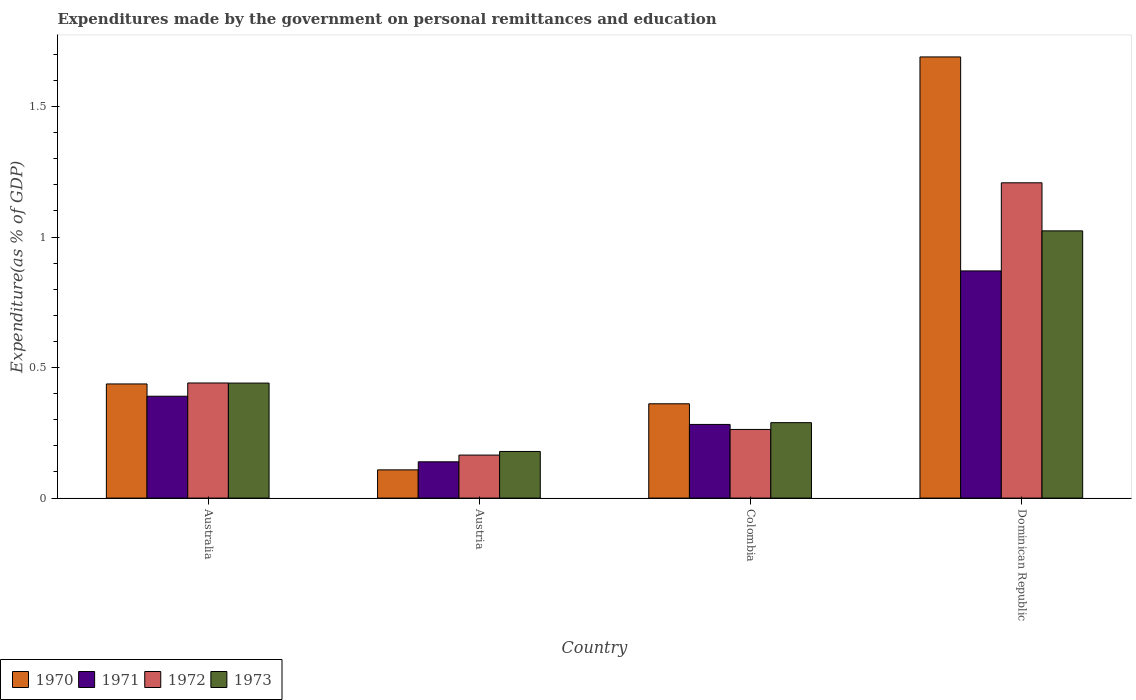How many bars are there on the 1st tick from the left?
Provide a short and direct response. 4. How many bars are there on the 1st tick from the right?
Give a very brief answer. 4. What is the expenditures made by the government on personal remittances and education in 1972 in Dominican Republic?
Ensure brevity in your answer.  1.21. Across all countries, what is the maximum expenditures made by the government on personal remittances and education in 1972?
Offer a very short reply. 1.21. Across all countries, what is the minimum expenditures made by the government on personal remittances and education in 1971?
Make the answer very short. 0.14. In which country was the expenditures made by the government on personal remittances and education in 1971 maximum?
Ensure brevity in your answer.  Dominican Republic. What is the total expenditures made by the government on personal remittances and education in 1971 in the graph?
Offer a terse response. 1.68. What is the difference between the expenditures made by the government on personal remittances and education in 1972 in Australia and that in Dominican Republic?
Keep it short and to the point. -0.77. What is the difference between the expenditures made by the government on personal remittances and education in 1972 in Dominican Republic and the expenditures made by the government on personal remittances and education in 1971 in Austria?
Offer a very short reply. 1.07. What is the average expenditures made by the government on personal remittances and education in 1970 per country?
Keep it short and to the point. 0.65. What is the difference between the expenditures made by the government on personal remittances and education of/in 1971 and expenditures made by the government on personal remittances and education of/in 1970 in Dominican Republic?
Make the answer very short. -0.82. In how many countries, is the expenditures made by the government on personal remittances and education in 1972 greater than 1.6 %?
Keep it short and to the point. 0. What is the ratio of the expenditures made by the government on personal remittances and education in 1971 in Austria to that in Dominican Republic?
Provide a succinct answer. 0.16. Is the expenditures made by the government on personal remittances and education in 1971 in Australia less than that in Colombia?
Your response must be concise. No. Is the difference between the expenditures made by the government on personal remittances and education in 1971 in Austria and Dominican Republic greater than the difference between the expenditures made by the government on personal remittances and education in 1970 in Austria and Dominican Republic?
Ensure brevity in your answer.  Yes. What is the difference between the highest and the second highest expenditures made by the government on personal remittances and education in 1970?
Ensure brevity in your answer.  -1.25. What is the difference between the highest and the lowest expenditures made by the government on personal remittances and education in 1971?
Your answer should be compact. 0.73. In how many countries, is the expenditures made by the government on personal remittances and education in 1972 greater than the average expenditures made by the government on personal remittances and education in 1972 taken over all countries?
Provide a short and direct response. 1. What does the 3rd bar from the left in Australia represents?
Your answer should be compact. 1972. What does the 2nd bar from the right in Austria represents?
Give a very brief answer. 1972. Are all the bars in the graph horizontal?
Offer a very short reply. No. How many countries are there in the graph?
Provide a succinct answer. 4. Where does the legend appear in the graph?
Give a very brief answer. Bottom left. How many legend labels are there?
Make the answer very short. 4. What is the title of the graph?
Keep it short and to the point. Expenditures made by the government on personal remittances and education. What is the label or title of the Y-axis?
Your answer should be very brief. Expenditure(as % of GDP). What is the Expenditure(as % of GDP) in 1970 in Australia?
Your response must be concise. 0.44. What is the Expenditure(as % of GDP) of 1971 in Australia?
Ensure brevity in your answer.  0.39. What is the Expenditure(as % of GDP) in 1972 in Australia?
Provide a short and direct response. 0.44. What is the Expenditure(as % of GDP) of 1973 in Australia?
Your answer should be very brief. 0.44. What is the Expenditure(as % of GDP) of 1970 in Austria?
Ensure brevity in your answer.  0.11. What is the Expenditure(as % of GDP) of 1971 in Austria?
Give a very brief answer. 0.14. What is the Expenditure(as % of GDP) of 1972 in Austria?
Offer a terse response. 0.16. What is the Expenditure(as % of GDP) of 1973 in Austria?
Your answer should be very brief. 0.18. What is the Expenditure(as % of GDP) of 1970 in Colombia?
Ensure brevity in your answer.  0.36. What is the Expenditure(as % of GDP) of 1971 in Colombia?
Offer a very short reply. 0.28. What is the Expenditure(as % of GDP) in 1972 in Colombia?
Provide a succinct answer. 0.26. What is the Expenditure(as % of GDP) in 1973 in Colombia?
Make the answer very short. 0.29. What is the Expenditure(as % of GDP) of 1970 in Dominican Republic?
Offer a terse response. 1.69. What is the Expenditure(as % of GDP) of 1971 in Dominican Republic?
Provide a succinct answer. 0.87. What is the Expenditure(as % of GDP) in 1972 in Dominican Republic?
Your answer should be very brief. 1.21. What is the Expenditure(as % of GDP) in 1973 in Dominican Republic?
Provide a short and direct response. 1.02. Across all countries, what is the maximum Expenditure(as % of GDP) in 1970?
Give a very brief answer. 1.69. Across all countries, what is the maximum Expenditure(as % of GDP) in 1971?
Make the answer very short. 0.87. Across all countries, what is the maximum Expenditure(as % of GDP) in 1972?
Provide a succinct answer. 1.21. Across all countries, what is the maximum Expenditure(as % of GDP) of 1973?
Make the answer very short. 1.02. Across all countries, what is the minimum Expenditure(as % of GDP) in 1970?
Offer a terse response. 0.11. Across all countries, what is the minimum Expenditure(as % of GDP) of 1971?
Make the answer very short. 0.14. Across all countries, what is the minimum Expenditure(as % of GDP) in 1972?
Ensure brevity in your answer.  0.16. Across all countries, what is the minimum Expenditure(as % of GDP) in 1973?
Your answer should be compact. 0.18. What is the total Expenditure(as % of GDP) in 1970 in the graph?
Your response must be concise. 2.6. What is the total Expenditure(as % of GDP) in 1971 in the graph?
Provide a short and direct response. 1.68. What is the total Expenditure(as % of GDP) in 1972 in the graph?
Your answer should be compact. 2.08. What is the total Expenditure(as % of GDP) of 1973 in the graph?
Provide a short and direct response. 1.93. What is the difference between the Expenditure(as % of GDP) in 1970 in Australia and that in Austria?
Your answer should be very brief. 0.33. What is the difference between the Expenditure(as % of GDP) in 1971 in Australia and that in Austria?
Provide a short and direct response. 0.25. What is the difference between the Expenditure(as % of GDP) in 1972 in Australia and that in Austria?
Offer a very short reply. 0.28. What is the difference between the Expenditure(as % of GDP) in 1973 in Australia and that in Austria?
Offer a very short reply. 0.26. What is the difference between the Expenditure(as % of GDP) in 1970 in Australia and that in Colombia?
Provide a short and direct response. 0.08. What is the difference between the Expenditure(as % of GDP) in 1971 in Australia and that in Colombia?
Ensure brevity in your answer.  0.11. What is the difference between the Expenditure(as % of GDP) in 1972 in Australia and that in Colombia?
Provide a short and direct response. 0.18. What is the difference between the Expenditure(as % of GDP) in 1973 in Australia and that in Colombia?
Give a very brief answer. 0.15. What is the difference between the Expenditure(as % of GDP) in 1970 in Australia and that in Dominican Republic?
Provide a succinct answer. -1.25. What is the difference between the Expenditure(as % of GDP) in 1971 in Australia and that in Dominican Republic?
Your answer should be compact. -0.48. What is the difference between the Expenditure(as % of GDP) of 1972 in Australia and that in Dominican Republic?
Ensure brevity in your answer.  -0.77. What is the difference between the Expenditure(as % of GDP) of 1973 in Australia and that in Dominican Republic?
Provide a short and direct response. -0.58. What is the difference between the Expenditure(as % of GDP) in 1970 in Austria and that in Colombia?
Give a very brief answer. -0.25. What is the difference between the Expenditure(as % of GDP) of 1971 in Austria and that in Colombia?
Your answer should be very brief. -0.14. What is the difference between the Expenditure(as % of GDP) in 1972 in Austria and that in Colombia?
Your response must be concise. -0.1. What is the difference between the Expenditure(as % of GDP) in 1973 in Austria and that in Colombia?
Your answer should be compact. -0.11. What is the difference between the Expenditure(as % of GDP) of 1970 in Austria and that in Dominican Republic?
Offer a terse response. -1.58. What is the difference between the Expenditure(as % of GDP) of 1971 in Austria and that in Dominican Republic?
Offer a terse response. -0.73. What is the difference between the Expenditure(as % of GDP) in 1972 in Austria and that in Dominican Republic?
Your answer should be compact. -1.04. What is the difference between the Expenditure(as % of GDP) in 1973 in Austria and that in Dominican Republic?
Offer a very short reply. -0.84. What is the difference between the Expenditure(as % of GDP) in 1970 in Colombia and that in Dominican Republic?
Keep it short and to the point. -1.33. What is the difference between the Expenditure(as % of GDP) in 1971 in Colombia and that in Dominican Republic?
Offer a very short reply. -0.59. What is the difference between the Expenditure(as % of GDP) of 1972 in Colombia and that in Dominican Republic?
Make the answer very short. -0.94. What is the difference between the Expenditure(as % of GDP) in 1973 in Colombia and that in Dominican Republic?
Your answer should be very brief. -0.73. What is the difference between the Expenditure(as % of GDP) of 1970 in Australia and the Expenditure(as % of GDP) of 1971 in Austria?
Ensure brevity in your answer.  0.3. What is the difference between the Expenditure(as % of GDP) in 1970 in Australia and the Expenditure(as % of GDP) in 1972 in Austria?
Your response must be concise. 0.27. What is the difference between the Expenditure(as % of GDP) in 1970 in Australia and the Expenditure(as % of GDP) in 1973 in Austria?
Ensure brevity in your answer.  0.26. What is the difference between the Expenditure(as % of GDP) of 1971 in Australia and the Expenditure(as % of GDP) of 1972 in Austria?
Ensure brevity in your answer.  0.23. What is the difference between the Expenditure(as % of GDP) in 1971 in Australia and the Expenditure(as % of GDP) in 1973 in Austria?
Offer a terse response. 0.21. What is the difference between the Expenditure(as % of GDP) in 1972 in Australia and the Expenditure(as % of GDP) in 1973 in Austria?
Give a very brief answer. 0.26. What is the difference between the Expenditure(as % of GDP) of 1970 in Australia and the Expenditure(as % of GDP) of 1971 in Colombia?
Your response must be concise. 0.15. What is the difference between the Expenditure(as % of GDP) of 1970 in Australia and the Expenditure(as % of GDP) of 1972 in Colombia?
Your answer should be compact. 0.17. What is the difference between the Expenditure(as % of GDP) of 1970 in Australia and the Expenditure(as % of GDP) of 1973 in Colombia?
Provide a short and direct response. 0.15. What is the difference between the Expenditure(as % of GDP) in 1971 in Australia and the Expenditure(as % of GDP) in 1972 in Colombia?
Your response must be concise. 0.13. What is the difference between the Expenditure(as % of GDP) in 1971 in Australia and the Expenditure(as % of GDP) in 1973 in Colombia?
Keep it short and to the point. 0.1. What is the difference between the Expenditure(as % of GDP) of 1972 in Australia and the Expenditure(as % of GDP) of 1973 in Colombia?
Keep it short and to the point. 0.15. What is the difference between the Expenditure(as % of GDP) of 1970 in Australia and the Expenditure(as % of GDP) of 1971 in Dominican Republic?
Provide a short and direct response. -0.43. What is the difference between the Expenditure(as % of GDP) of 1970 in Australia and the Expenditure(as % of GDP) of 1972 in Dominican Republic?
Offer a very short reply. -0.77. What is the difference between the Expenditure(as % of GDP) of 1970 in Australia and the Expenditure(as % of GDP) of 1973 in Dominican Republic?
Provide a short and direct response. -0.59. What is the difference between the Expenditure(as % of GDP) in 1971 in Australia and the Expenditure(as % of GDP) in 1972 in Dominican Republic?
Give a very brief answer. -0.82. What is the difference between the Expenditure(as % of GDP) in 1971 in Australia and the Expenditure(as % of GDP) in 1973 in Dominican Republic?
Your answer should be compact. -0.63. What is the difference between the Expenditure(as % of GDP) of 1972 in Australia and the Expenditure(as % of GDP) of 1973 in Dominican Republic?
Your response must be concise. -0.58. What is the difference between the Expenditure(as % of GDP) in 1970 in Austria and the Expenditure(as % of GDP) in 1971 in Colombia?
Keep it short and to the point. -0.17. What is the difference between the Expenditure(as % of GDP) of 1970 in Austria and the Expenditure(as % of GDP) of 1972 in Colombia?
Your answer should be compact. -0.15. What is the difference between the Expenditure(as % of GDP) of 1970 in Austria and the Expenditure(as % of GDP) of 1973 in Colombia?
Ensure brevity in your answer.  -0.18. What is the difference between the Expenditure(as % of GDP) of 1971 in Austria and the Expenditure(as % of GDP) of 1972 in Colombia?
Keep it short and to the point. -0.12. What is the difference between the Expenditure(as % of GDP) of 1971 in Austria and the Expenditure(as % of GDP) of 1973 in Colombia?
Provide a succinct answer. -0.15. What is the difference between the Expenditure(as % of GDP) in 1972 in Austria and the Expenditure(as % of GDP) in 1973 in Colombia?
Your answer should be very brief. -0.12. What is the difference between the Expenditure(as % of GDP) in 1970 in Austria and the Expenditure(as % of GDP) in 1971 in Dominican Republic?
Your answer should be compact. -0.76. What is the difference between the Expenditure(as % of GDP) of 1970 in Austria and the Expenditure(as % of GDP) of 1972 in Dominican Republic?
Your answer should be compact. -1.1. What is the difference between the Expenditure(as % of GDP) of 1970 in Austria and the Expenditure(as % of GDP) of 1973 in Dominican Republic?
Make the answer very short. -0.92. What is the difference between the Expenditure(as % of GDP) of 1971 in Austria and the Expenditure(as % of GDP) of 1972 in Dominican Republic?
Provide a short and direct response. -1.07. What is the difference between the Expenditure(as % of GDP) of 1971 in Austria and the Expenditure(as % of GDP) of 1973 in Dominican Republic?
Keep it short and to the point. -0.88. What is the difference between the Expenditure(as % of GDP) in 1972 in Austria and the Expenditure(as % of GDP) in 1973 in Dominican Republic?
Keep it short and to the point. -0.86. What is the difference between the Expenditure(as % of GDP) in 1970 in Colombia and the Expenditure(as % of GDP) in 1971 in Dominican Republic?
Provide a succinct answer. -0.51. What is the difference between the Expenditure(as % of GDP) of 1970 in Colombia and the Expenditure(as % of GDP) of 1972 in Dominican Republic?
Give a very brief answer. -0.85. What is the difference between the Expenditure(as % of GDP) of 1970 in Colombia and the Expenditure(as % of GDP) of 1973 in Dominican Republic?
Your answer should be very brief. -0.66. What is the difference between the Expenditure(as % of GDP) in 1971 in Colombia and the Expenditure(as % of GDP) in 1972 in Dominican Republic?
Provide a short and direct response. -0.93. What is the difference between the Expenditure(as % of GDP) of 1971 in Colombia and the Expenditure(as % of GDP) of 1973 in Dominican Republic?
Your answer should be very brief. -0.74. What is the difference between the Expenditure(as % of GDP) in 1972 in Colombia and the Expenditure(as % of GDP) in 1973 in Dominican Republic?
Offer a very short reply. -0.76. What is the average Expenditure(as % of GDP) in 1970 per country?
Ensure brevity in your answer.  0.65. What is the average Expenditure(as % of GDP) of 1971 per country?
Your answer should be very brief. 0.42. What is the average Expenditure(as % of GDP) in 1972 per country?
Provide a succinct answer. 0.52. What is the average Expenditure(as % of GDP) in 1973 per country?
Your answer should be compact. 0.48. What is the difference between the Expenditure(as % of GDP) in 1970 and Expenditure(as % of GDP) in 1971 in Australia?
Your answer should be compact. 0.05. What is the difference between the Expenditure(as % of GDP) in 1970 and Expenditure(as % of GDP) in 1972 in Australia?
Your answer should be compact. -0. What is the difference between the Expenditure(as % of GDP) in 1970 and Expenditure(as % of GDP) in 1973 in Australia?
Keep it short and to the point. -0. What is the difference between the Expenditure(as % of GDP) in 1971 and Expenditure(as % of GDP) in 1972 in Australia?
Your response must be concise. -0.05. What is the difference between the Expenditure(as % of GDP) in 1971 and Expenditure(as % of GDP) in 1973 in Australia?
Your response must be concise. -0.05. What is the difference between the Expenditure(as % of GDP) of 1970 and Expenditure(as % of GDP) of 1971 in Austria?
Ensure brevity in your answer.  -0.03. What is the difference between the Expenditure(as % of GDP) in 1970 and Expenditure(as % of GDP) in 1972 in Austria?
Offer a very short reply. -0.06. What is the difference between the Expenditure(as % of GDP) in 1970 and Expenditure(as % of GDP) in 1973 in Austria?
Offer a very short reply. -0.07. What is the difference between the Expenditure(as % of GDP) of 1971 and Expenditure(as % of GDP) of 1972 in Austria?
Provide a succinct answer. -0.03. What is the difference between the Expenditure(as % of GDP) in 1971 and Expenditure(as % of GDP) in 1973 in Austria?
Make the answer very short. -0.04. What is the difference between the Expenditure(as % of GDP) in 1972 and Expenditure(as % of GDP) in 1973 in Austria?
Make the answer very short. -0.01. What is the difference between the Expenditure(as % of GDP) in 1970 and Expenditure(as % of GDP) in 1971 in Colombia?
Provide a short and direct response. 0.08. What is the difference between the Expenditure(as % of GDP) of 1970 and Expenditure(as % of GDP) of 1972 in Colombia?
Ensure brevity in your answer.  0.1. What is the difference between the Expenditure(as % of GDP) of 1970 and Expenditure(as % of GDP) of 1973 in Colombia?
Provide a succinct answer. 0.07. What is the difference between the Expenditure(as % of GDP) of 1971 and Expenditure(as % of GDP) of 1972 in Colombia?
Offer a very short reply. 0.02. What is the difference between the Expenditure(as % of GDP) in 1971 and Expenditure(as % of GDP) in 1973 in Colombia?
Offer a terse response. -0.01. What is the difference between the Expenditure(as % of GDP) of 1972 and Expenditure(as % of GDP) of 1973 in Colombia?
Offer a very short reply. -0.03. What is the difference between the Expenditure(as % of GDP) in 1970 and Expenditure(as % of GDP) in 1971 in Dominican Republic?
Offer a very short reply. 0.82. What is the difference between the Expenditure(as % of GDP) in 1970 and Expenditure(as % of GDP) in 1972 in Dominican Republic?
Give a very brief answer. 0.48. What is the difference between the Expenditure(as % of GDP) of 1970 and Expenditure(as % of GDP) of 1973 in Dominican Republic?
Your answer should be very brief. 0.67. What is the difference between the Expenditure(as % of GDP) of 1971 and Expenditure(as % of GDP) of 1972 in Dominican Republic?
Offer a very short reply. -0.34. What is the difference between the Expenditure(as % of GDP) in 1971 and Expenditure(as % of GDP) in 1973 in Dominican Republic?
Provide a succinct answer. -0.15. What is the difference between the Expenditure(as % of GDP) in 1972 and Expenditure(as % of GDP) in 1973 in Dominican Republic?
Offer a very short reply. 0.18. What is the ratio of the Expenditure(as % of GDP) of 1970 in Australia to that in Austria?
Provide a succinct answer. 4.04. What is the ratio of the Expenditure(as % of GDP) of 1971 in Australia to that in Austria?
Keep it short and to the point. 2.81. What is the ratio of the Expenditure(as % of GDP) in 1972 in Australia to that in Austria?
Provide a short and direct response. 2.68. What is the ratio of the Expenditure(as % of GDP) of 1973 in Australia to that in Austria?
Your response must be concise. 2.47. What is the ratio of the Expenditure(as % of GDP) of 1970 in Australia to that in Colombia?
Provide a short and direct response. 1.21. What is the ratio of the Expenditure(as % of GDP) in 1971 in Australia to that in Colombia?
Make the answer very short. 1.38. What is the ratio of the Expenditure(as % of GDP) of 1972 in Australia to that in Colombia?
Provide a short and direct response. 1.68. What is the ratio of the Expenditure(as % of GDP) in 1973 in Australia to that in Colombia?
Ensure brevity in your answer.  1.52. What is the ratio of the Expenditure(as % of GDP) of 1970 in Australia to that in Dominican Republic?
Offer a very short reply. 0.26. What is the ratio of the Expenditure(as % of GDP) in 1971 in Australia to that in Dominican Republic?
Provide a short and direct response. 0.45. What is the ratio of the Expenditure(as % of GDP) of 1972 in Australia to that in Dominican Republic?
Provide a succinct answer. 0.37. What is the ratio of the Expenditure(as % of GDP) of 1973 in Australia to that in Dominican Republic?
Your response must be concise. 0.43. What is the ratio of the Expenditure(as % of GDP) in 1970 in Austria to that in Colombia?
Provide a succinct answer. 0.3. What is the ratio of the Expenditure(as % of GDP) of 1971 in Austria to that in Colombia?
Provide a short and direct response. 0.49. What is the ratio of the Expenditure(as % of GDP) in 1972 in Austria to that in Colombia?
Provide a succinct answer. 0.63. What is the ratio of the Expenditure(as % of GDP) of 1973 in Austria to that in Colombia?
Make the answer very short. 0.62. What is the ratio of the Expenditure(as % of GDP) of 1970 in Austria to that in Dominican Republic?
Give a very brief answer. 0.06. What is the ratio of the Expenditure(as % of GDP) in 1971 in Austria to that in Dominican Republic?
Ensure brevity in your answer.  0.16. What is the ratio of the Expenditure(as % of GDP) in 1972 in Austria to that in Dominican Republic?
Provide a short and direct response. 0.14. What is the ratio of the Expenditure(as % of GDP) of 1973 in Austria to that in Dominican Republic?
Make the answer very short. 0.17. What is the ratio of the Expenditure(as % of GDP) of 1970 in Colombia to that in Dominican Republic?
Provide a succinct answer. 0.21. What is the ratio of the Expenditure(as % of GDP) in 1971 in Colombia to that in Dominican Republic?
Offer a very short reply. 0.32. What is the ratio of the Expenditure(as % of GDP) of 1972 in Colombia to that in Dominican Republic?
Your answer should be compact. 0.22. What is the ratio of the Expenditure(as % of GDP) in 1973 in Colombia to that in Dominican Republic?
Your response must be concise. 0.28. What is the difference between the highest and the second highest Expenditure(as % of GDP) in 1970?
Give a very brief answer. 1.25. What is the difference between the highest and the second highest Expenditure(as % of GDP) in 1971?
Offer a terse response. 0.48. What is the difference between the highest and the second highest Expenditure(as % of GDP) of 1972?
Provide a short and direct response. 0.77. What is the difference between the highest and the second highest Expenditure(as % of GDP) in 1973?
Your answer should be very brief. 0.58. What is the difference between the highest and the lowest Expenditure(as % of GDP) of 1970?
Offer a very short reply. 1.58. What is the difference between the highest and the lowest Expenditure(as % of GDP) in 1971?
Keep it short and to the point. 0.73. What is the difference between the highest and the lowest Expenditure(as % of GDP) in 1972?
Give a very brief answer. 1.04. What is the difference between the highest and the lowest Expenditure(as % of GDP) of 1973?
Keep it short and to the point. 0.84. 